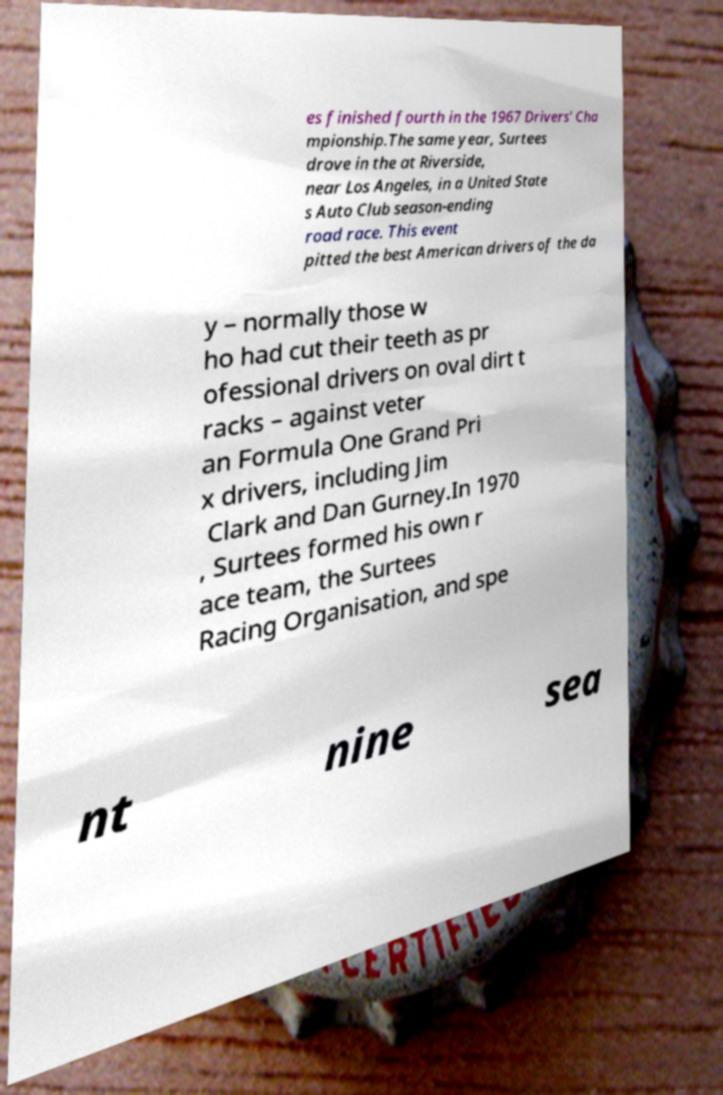Could you extract and type out the text from this image? es finished fourth in the 1967 Drivers' Cha mpionship.The same year, Surtees drove in the at Riverside, near Los Angeles, in a United State s Auto Club season-ending road race. This event pitted the best American drivers of the da y – normally those w ho had cut their teeth as pr ofessional drivers on oval dirt t racks – against veter an Formula One Grand Pri x drivers, including Jim Clark and Dan Gurney.In 1970 , Surtees formed his own r ace team, the Surtees Racing Organisation, and spe nt nine sea 